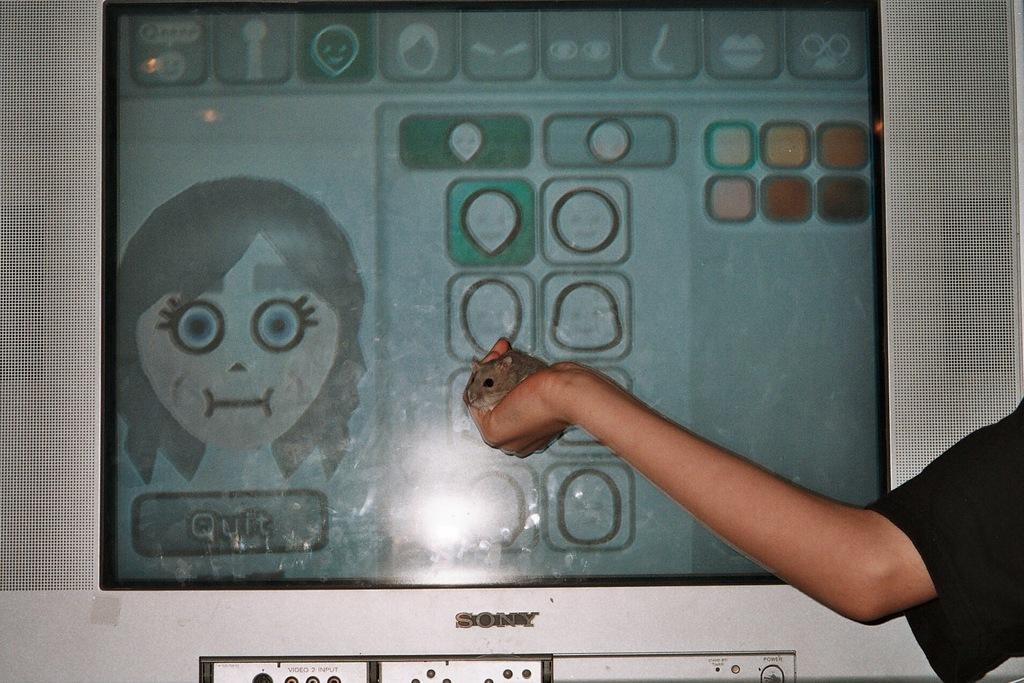What is being held by the person's hand in the image? There is a person's hand holding a mouse on the right side of the image. What can be seen in the background of the image? There is a television in the background of the image. What is the price of the plot of land in the image? There is no plot of land present in the image, so it is not possible to determine its price. 